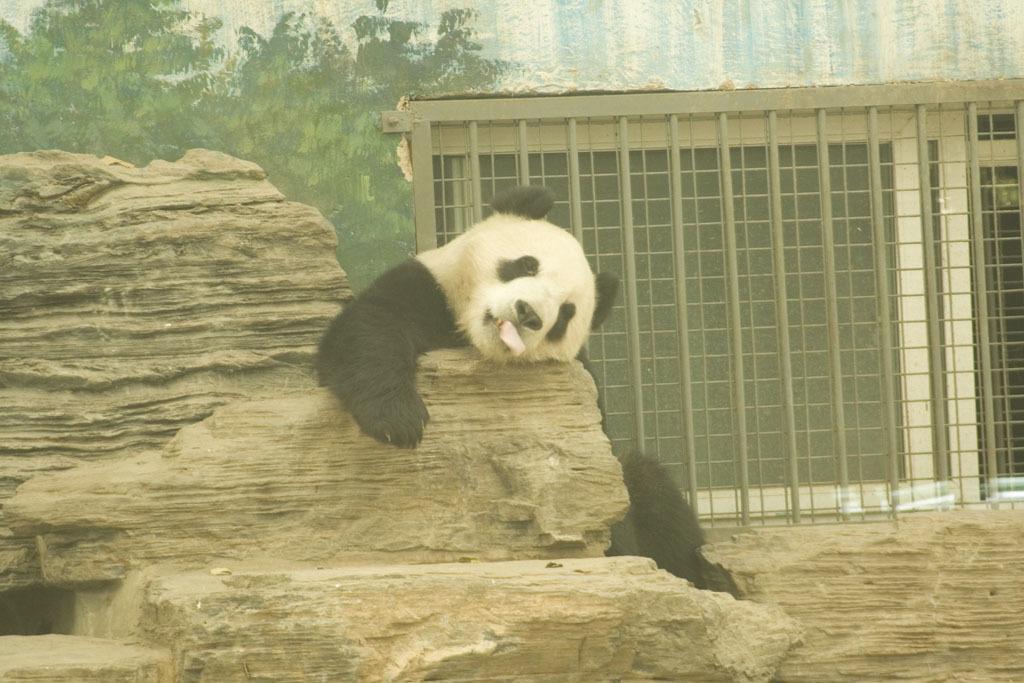How would you summarize this image in a sentence or two? A bear is sitting on the stone. It is in black and white color, on the left side there are trees. On the right side there is an iron grill in this image. 